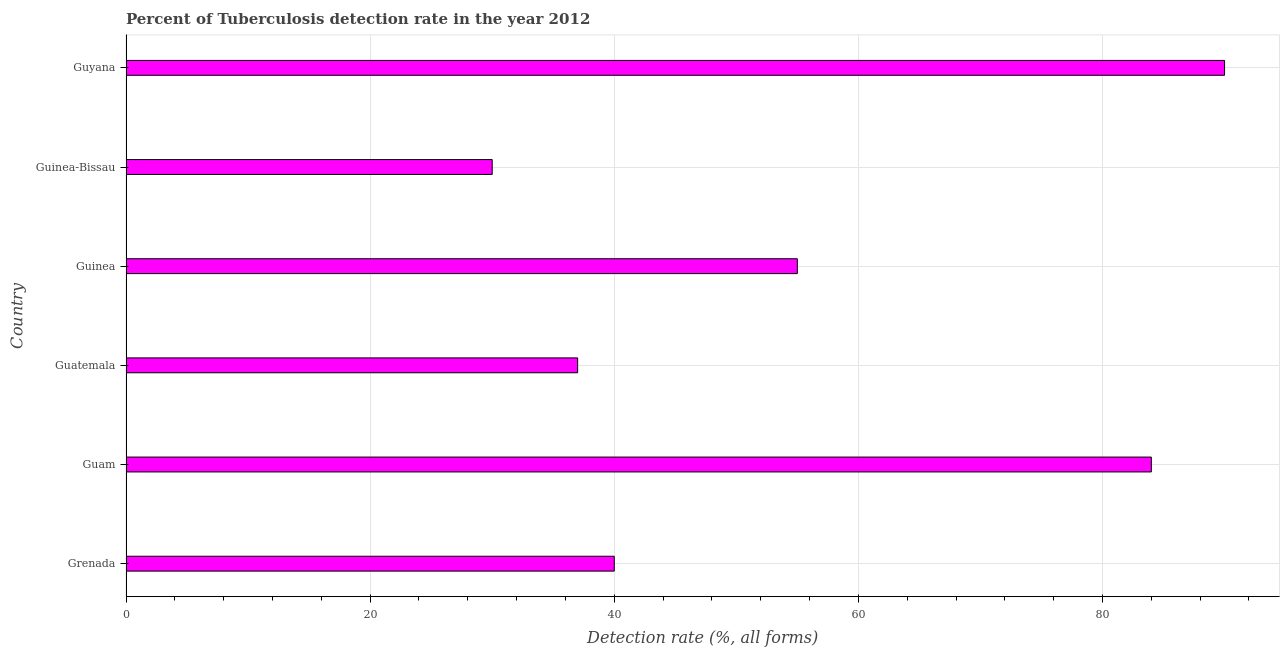Does the graph contain grids?
Ensure brevity in your answer.  Yes. What is the title of the graph?
Your answer should be very brief. Percent of Tuberculosis detection rate in the year 2012. What is the label or title of the X-axis?
Your response must be concise. Detection rate (%, all forms). What is the label or title of the Y-axis?
Give a very brief answer. Country. What is the detection rate of tuberculosis in Guinea?
Your answer should be compact. 55. Across all countries, what is the maximum detection rate of tuberculosis?
Offer a very short reply. 90. In which country was the detection rate of tuberculosis maximum?
Keep it short and to the point. Guyana. In which country was the detection rate of tuberculosis minimum?
Keep it short and to the point. Guinea-Bissau. What is the sum of the detection rate of tuberculosis?
Make the answer very short. 336. What is the difference between the detection rate of tuberculosis in Grenada and Guyana?
Provide a short and direct response. -50. What is the average detection rate of tuberculosis per country?
Give a very brief answer. 56. What is the median detection rate of tuberculosis?
Offer a very short reply. 47.5. In how many countries, is the detection rate of tuberculosis greater than 24 %?
Your answer should be very brief. 6. What is the ratio of the detection rate of tuberculosis in Grenada to that in Guatemala?
Your answer should be very brief. 1.08. What is the difference between the highest and the second highest detection rate of tuberculosis?
Provide a short and direct response. 6. What is the difference between the highest and the lowest detection rate of tuberculosis?
Offer a very short reply. 60. In how many countries, is the detection rate of tuberculosis greater than the average detection rate of tuberculosis taken over all countries?
Your answer should be very brief. 2. Are all the bars in the graph horizontal?
Give a very brief answer. Yes. Are the values on the major ticks of X-axis written in scientific E-notation?
Offer a very short reply. No. What is the Detection rate (%, all forms) of Guam?
Your response must be concise. 84. What is the Detection rate (%, all forms) in Guinea?
Your response must be concise. 55. What is the difference between the Detection rate (%, all forms) in Grenada and Guam?
Provide a succinct answer. -44. What is the difference between the Detection rate (%, all forms) in Grenada and Guatemala?
Your answer should be very brief. 3. What is the difference between the Detection rate (%, all forms) in Grenada and Guinea?
Ensure brevity in your answer.  -15. What is the difference between the Detection rate (%, all forms) in Guam and Guinea?
Offer a very short reply. 29. What is the difference between the Detection rate (%, all forms) in Guam and Guinea-Bissau?
Offer a terse response. 54. What is the difference between the Detection rate (%, all forms) in Guatemala and Guinea?
Give a very brief answer. -18. What is the difference between the Detection rate (%, all forms) in Guatemala and Guyana?
Make the answer very short. -53. What is the difference between the Detection rate (%, all forms) in Guinea and Guyana?
Ensure brevity in your answer.  -35. What is the difference between the Detection rate (%, all forms) in Guinea-Bissau and Guyana?
Your answer should be compact. -60. What is the ratio of the Detection rate (%, all forms) in Grenada to that in Guam?
Keep it short and to the point. 0.48. What is the ratio of the Detection rate (%, all forms) in Grenada to that in Guatemala?
Ensure brevity in your answer.  1.08. What is the ratio of the Detection rate (%, all forms) in Grenada to that in Guinea?
Make the answer very short. 0.73. What is the ratio of the Detection rate (%, all forms) in Grenada to that in Guinea-Bissau?
Your answer should be compact. 1.33. What is the ratio of the Detection rate (%, all forms) in Grenada to that in Guyana?
Make the answer very short. 0.44. What is the ratio of the Detection rate (%, all forms) in Guam to that in Guatemala?
Give a very brief answer. 2.27. What is the ratio of the Detection rate (%, all forms) in Guam to that in Guinea?
Give a very brief answer. 1.53. What is the ratio of the Detection rate (%, all forms) in Guam to that in Guyana?
Ensure brevity in your answer.  0.93. What is the ratio of the Detection rate (%, all forms) in Guatemala to that in Guinea?
Provide a short and direct response. 0.67. What is the ratio of the Detection rate (%, all forms) in Guatemala to that in Guinea-Bissau?
Give a very brief answer. 1.23. What is the ratio of the Detection rate (%, all forms) in Guatemala to that in Guyana?
Provide a short and direct response. 0.41. What is the ratio of the Detection rate (%, all forms) in Guinea to that in Guinea-Bissau?
Keep it short and to the point. 1.83. What is the ratio of the Detection rate (%, all forms) in Guinea to that in Guyana?
Ensure brevity in your answer.  0.61. What is the ratio of the Detection rate (%, all forms) in Guinea-Bissau to that in Guyana?
Ensure brevity in your answer.  0.33. 